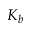Convert formula to latex. <formula><loc_0><loc_0><loc_500><loc_500>K _ { b }</formula> 